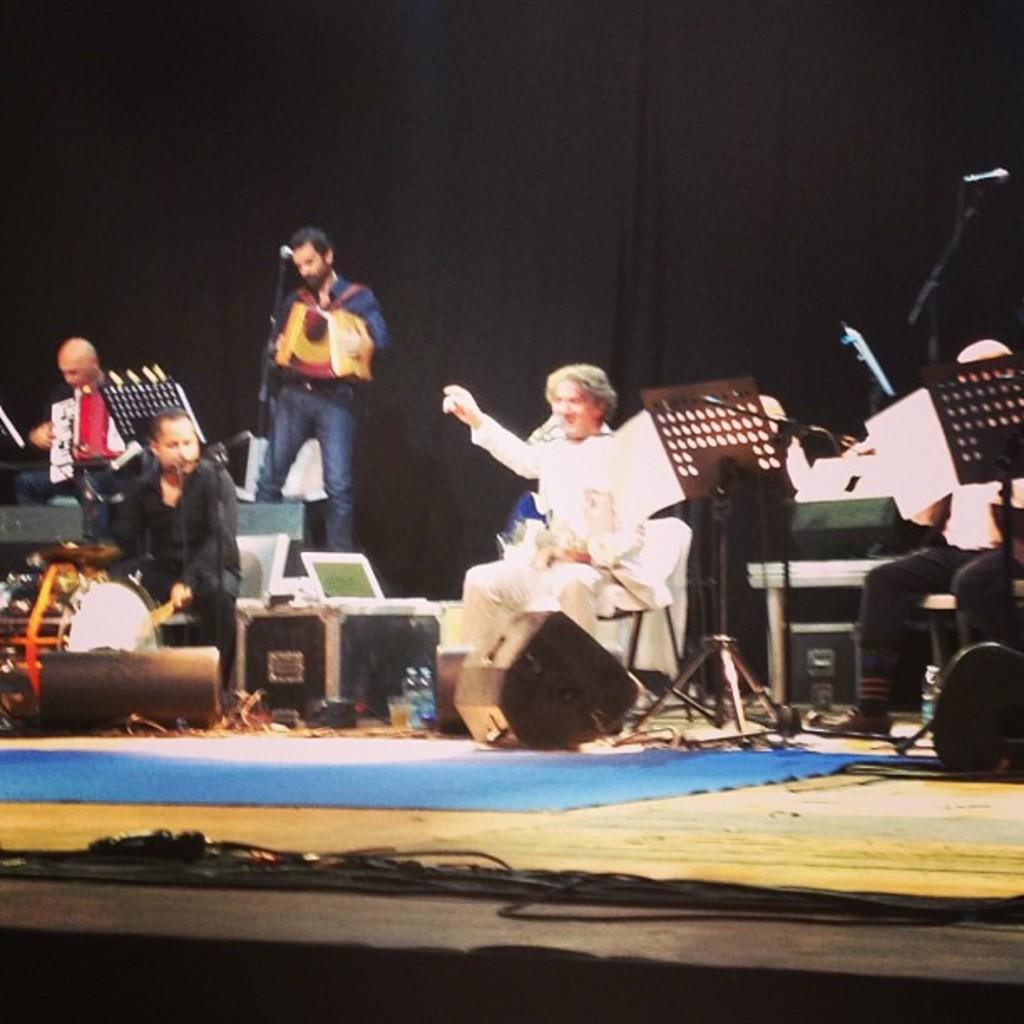What are the people in the image doing? The people in the image are playing musical instruments. What object is present in the image that is commonly used for amplifying sound? There is a microphone (mic) in the image. What type of flooring is visible in the image? There is a blue carpet in the image. What type of lunchroom is visible in the image? There is no lunchroom present in the image. What role does the governor play in the image? There is no governor present in the image. 